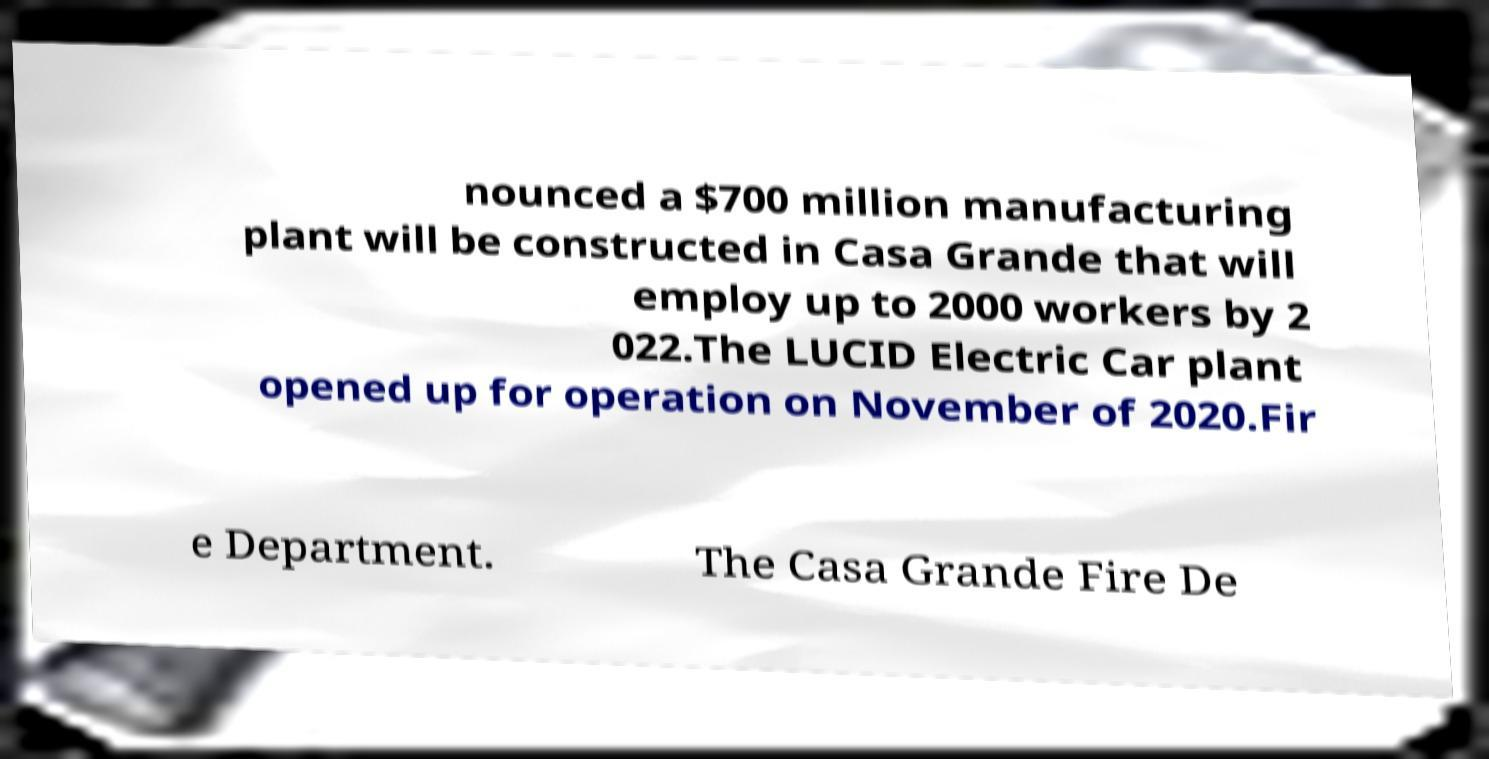Please identify and transcribe the text found in this image. nounced a $700 million manufacturing plant will be constructed in Casa Grande that will employ up to 2000 workers by 2 022.The LUCID Electric Car plant opened up for operation on November of 2020.Fir e Department. The Casa Grande Fire De 